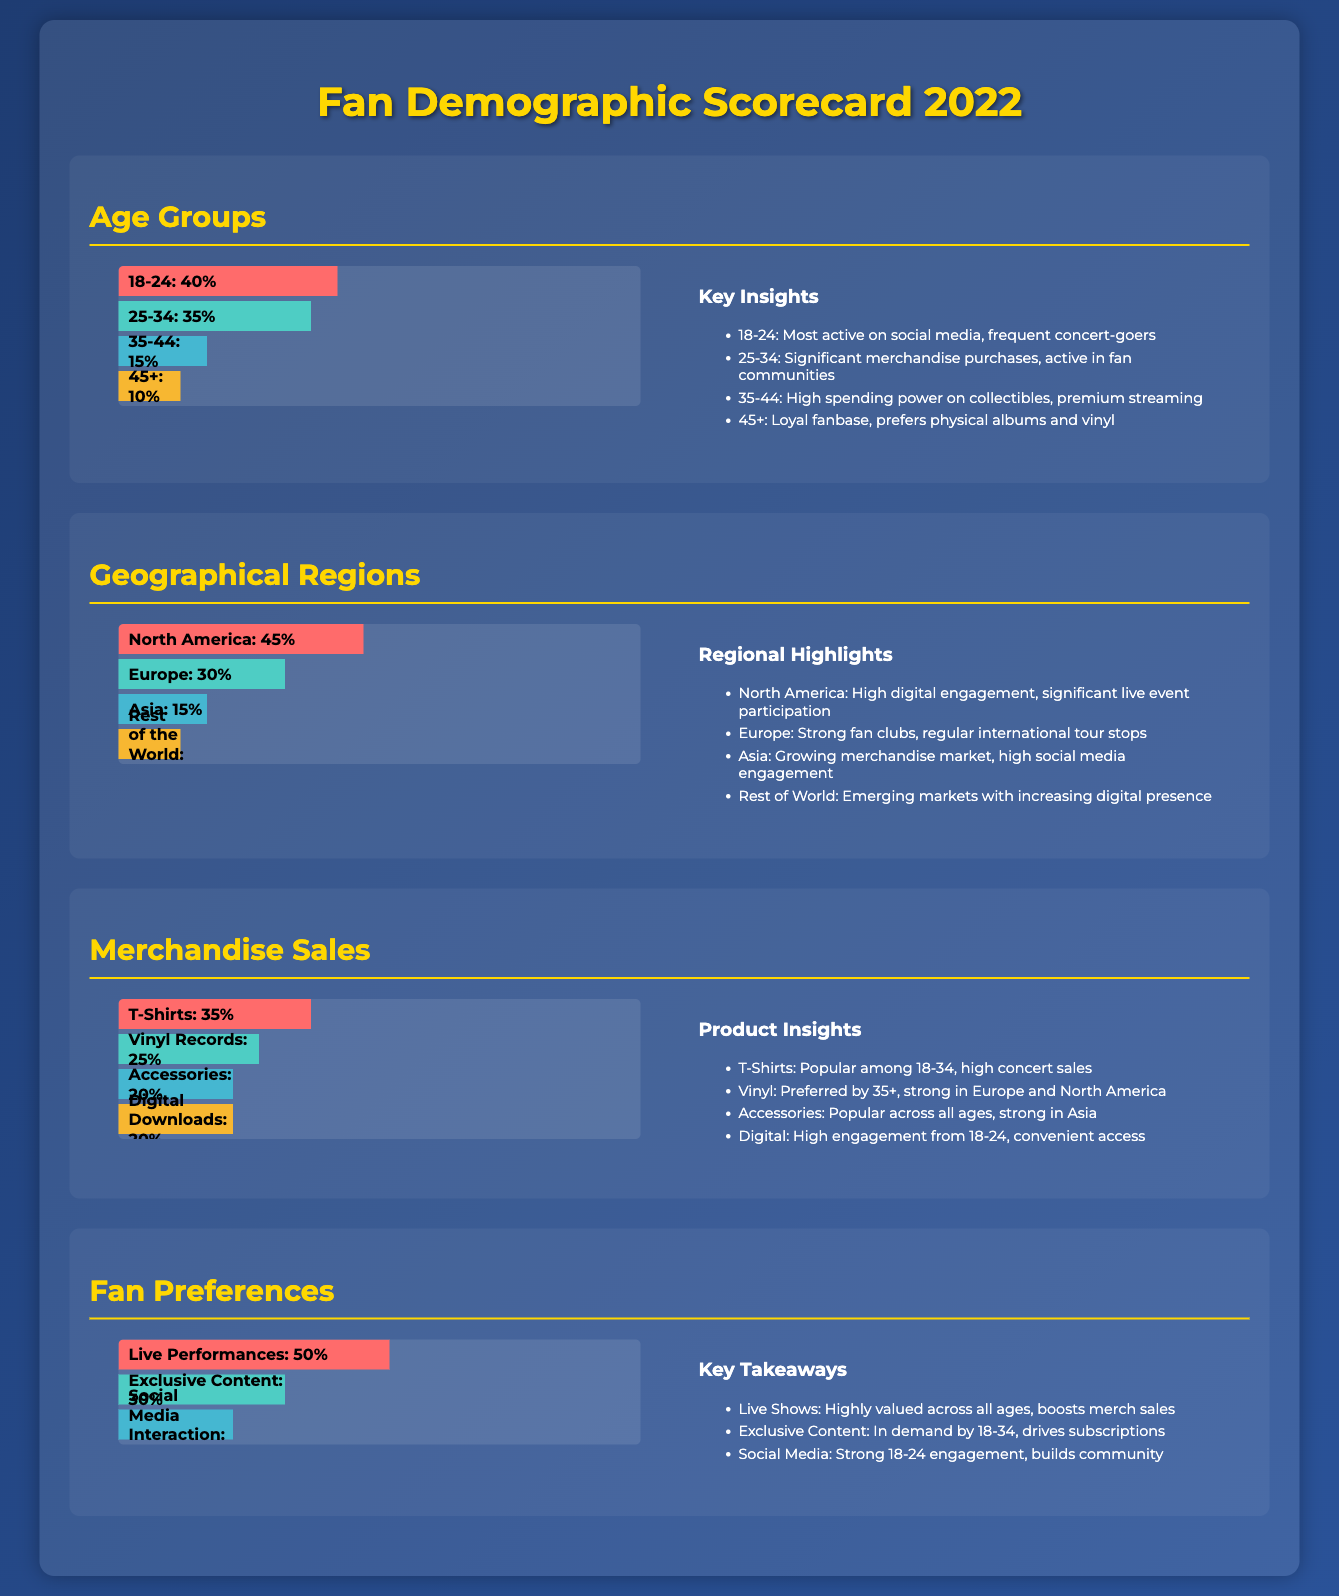What is the percentage of fans aged 18-24? The document states that 40% of fans belong to the age group 18-24.
Answer: 40% Which geographical region has the highest fan percentage? The document indicates that North America has the highest percentage at 45%.
Answer: North America What is the top-selling merchandise item? According to the document, T-Shirts have the highest percentage of sales at 35%.
Answer: T-Shirts What percentage of fans prefer live performances? The document shows that 50% of fans value live performances the most.
Answer: 50% Which age group is most active on social media? The document notes that the 18-24 age group is most active on social media.
Answer: 18-24 What is the percentage of fans aged 35-44? The document states that 15% of fans belong to the age group 35-44.
Answer: 15% What percentage of merchandise sales do Vinyl Records account for? The document specifies that Vinyl Records account for 25% of merchandise sales.
Answer: 25% Which demographic shows strong engagement for exclusive content? The document highlights that the 18-34 age group demands exclusive content.
Answer: 18-34 Which region is noted for having strong fan clubs? The document mentions that Europe has strong fan clubs among fans.
Answer: Europe 